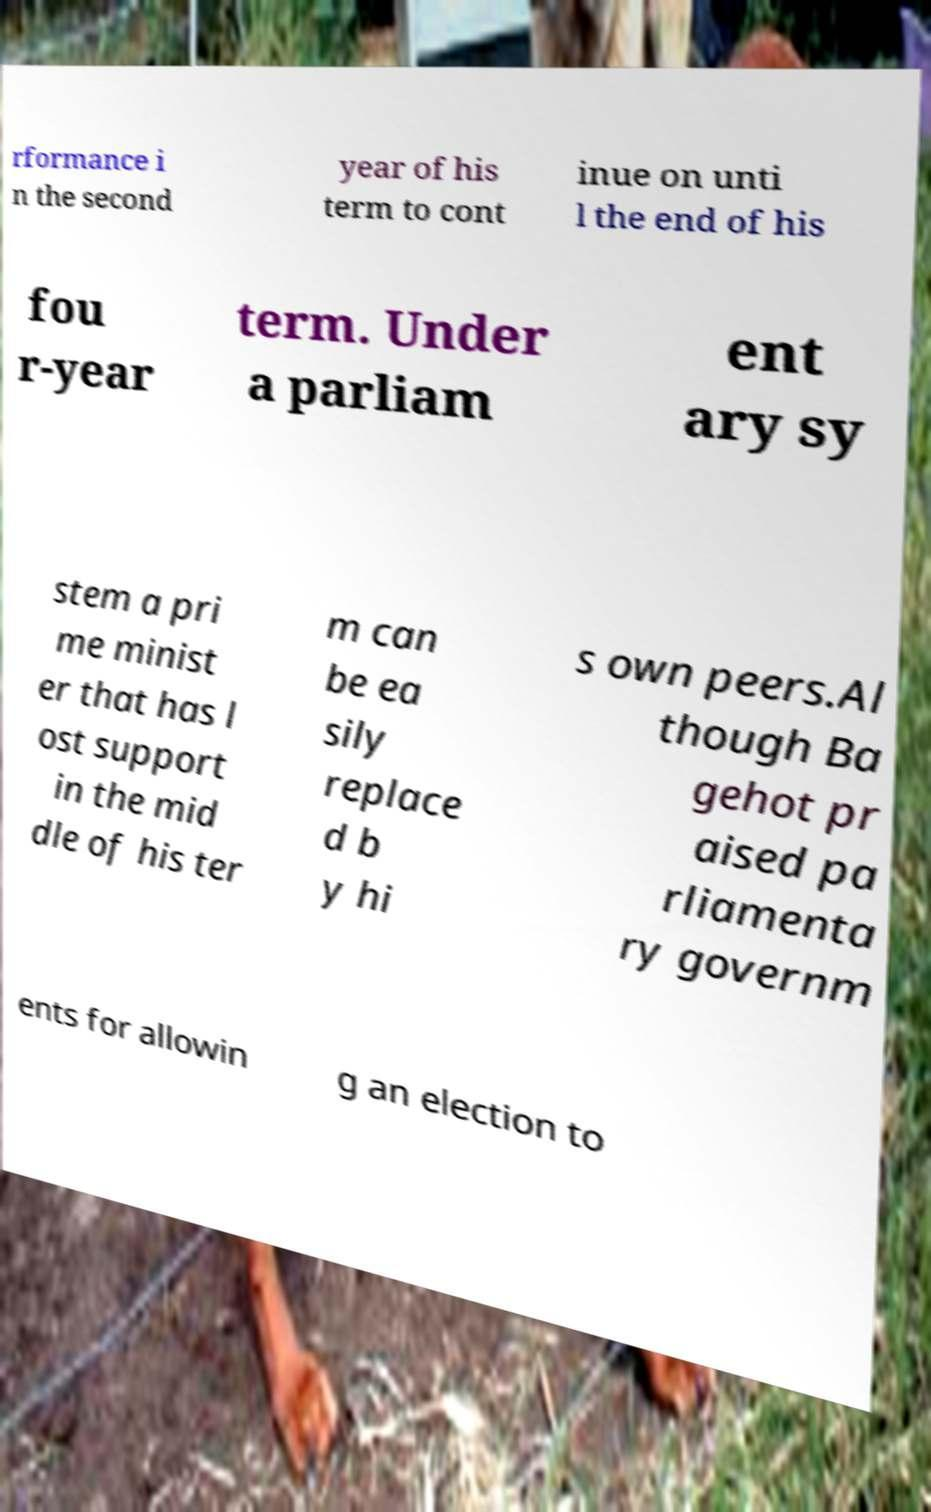Can you read and provide the text displayed in the image?This photo seems to have some interesting text. Can you extract and type it out for me? rformance i n the second year of his term to cont inue on unti l the end of his fou r-year term. Under a parliam ent ary sy stem a pri me minist er that has l ost support in the mid dle of his ter m can be ea sily replace d b y hi s own peers.Al though Ba gehot pr aised pa rliamenta ry governm ents for allowin g an election to 